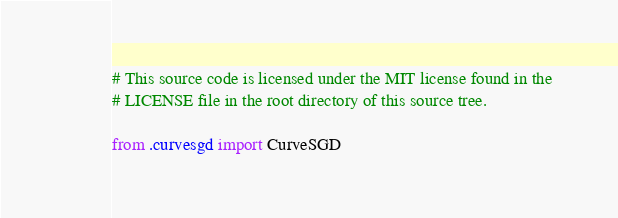Convert code to text. <code><loc_0><loc_0><loc_500><loc_500><_Python_># This source code is licensed under the MIT license found in the
# LICENSE file in the root directory of this source tree.

from .curvesgd import CurveSGD</code> 